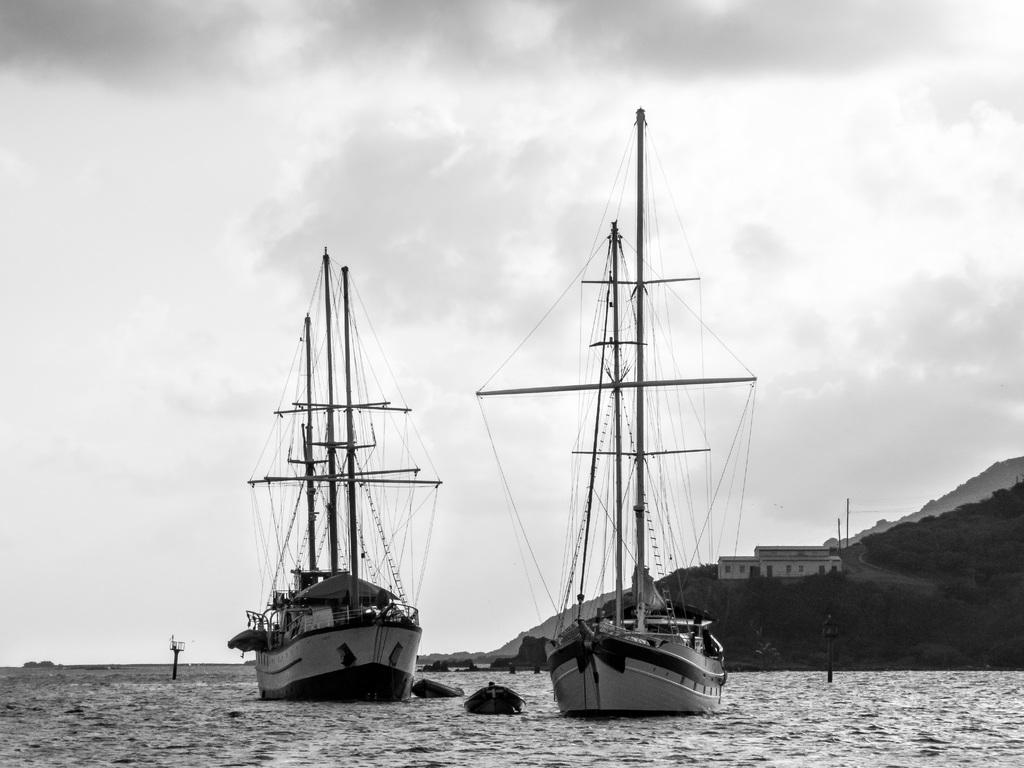What is in the water in the image? There are boats and objects in the water in the image. What can be seen in the background of the image? There is a house and poles in the background. What is the condition of the sky in the image? The sky is cloudy in the image. What is the limit of the boats in the image? There is no limit mentioned for the boats in the image, and the number of boats is not specified. What caption is written on the image? There is no caption present in the image. Can you see any eyes in the image? There are no eyes visible in the image. 